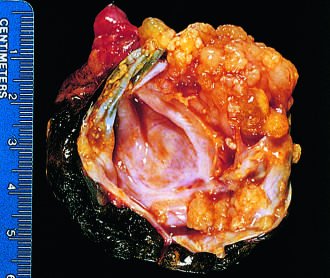what is opened to display a cyst cavity lined by delicate papillary tumor growths?
Answer the question using a single word or phrase. Borderline serous cystadenoma 